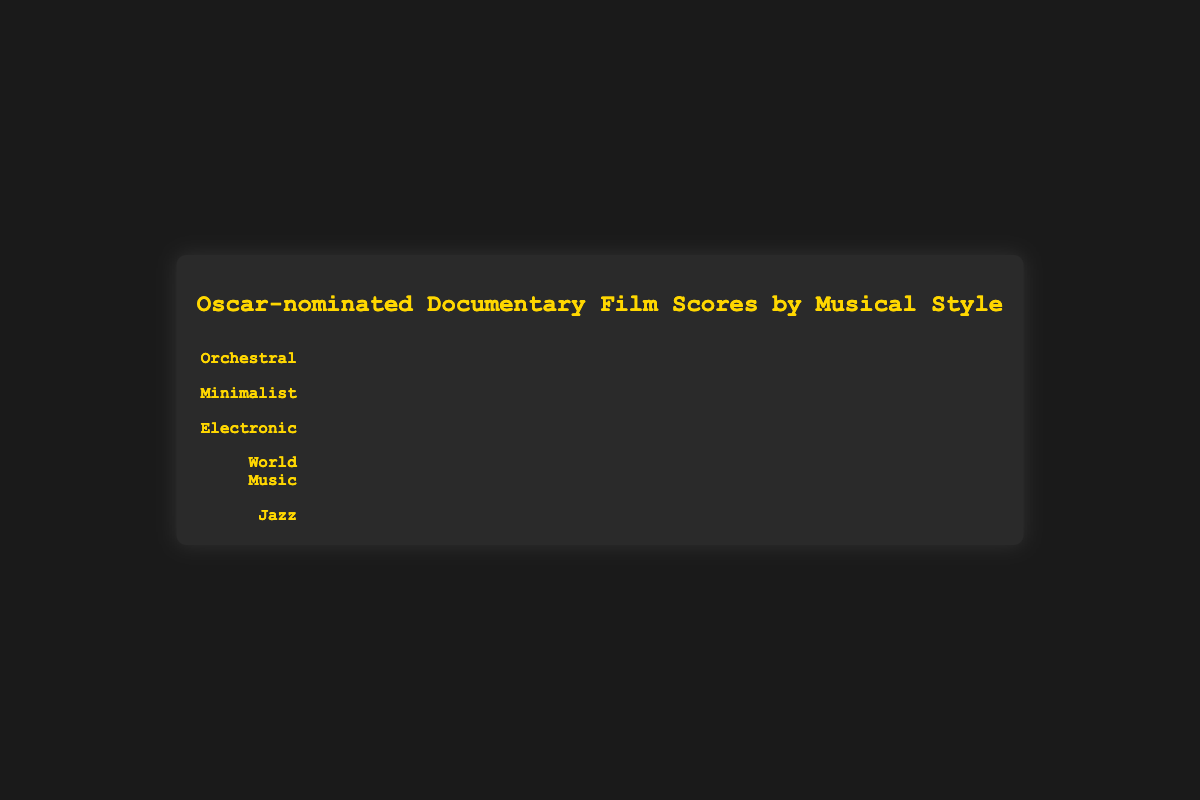Which musical style has the highest count of Oscar-nominated documentary film scores? To find which musical style has the highest count, look at the figure and identify the style with the most icons. In this case, it's the "Orchestral" style.
Answer: Orchestral How many Oscar-nominated documentary films used a Jazz musical style? Find the row labeled "Jazz," and count the icons in that row. There are 4 icons present.
Answer: 4 What is the sum of the counts for Minimalist and Electronic musical styles? Add the counts of the Minimalist (8) and Electronic (6) styles. The sum is 8 + 6 = 14.
Answer: 14 Which musical style has more examples, World Music or Jazz? Compare the counts of World Music (5) and Jazz (4) styles. World Music has more examples.
Answer: World Music How many more Oscar-nominated documentary films used Orchestral style compared to Minimalist style? Subtract the count of the Minimalist style (8) from the Orchestral style (15). The result is 15 - 8 = 7.
Answer: 7 If you were to average the counts of all the musical styles, what would that average be? Add all the counts (15 + 8 + 6 + 5 + 4) and divide by the number of styles (5). The sum is 38, so the average is 38 / 5 = 7.6.
Answer: 7.6 Which musical style is the least represented among the Oscar-nominated documentary film scores? Identify the row with the fewest icons. Jazz has the fewest icons with a count of 4.
Answer: Jazz How many musical styles have a count greater than 5? Check each style's count and see which ones have a count greater than 5. Orchestral and Minimalist have counts greater than 5. Therefore, 2 styles meet the criteria.
Answer: 2 Can you name one of the example documentary films associated with the Electronic musical style? Look at the row labeled "Electronic" and check the examples listed. One of the examples is "The Social Dilemma."
Answer: The Social Dilemma 